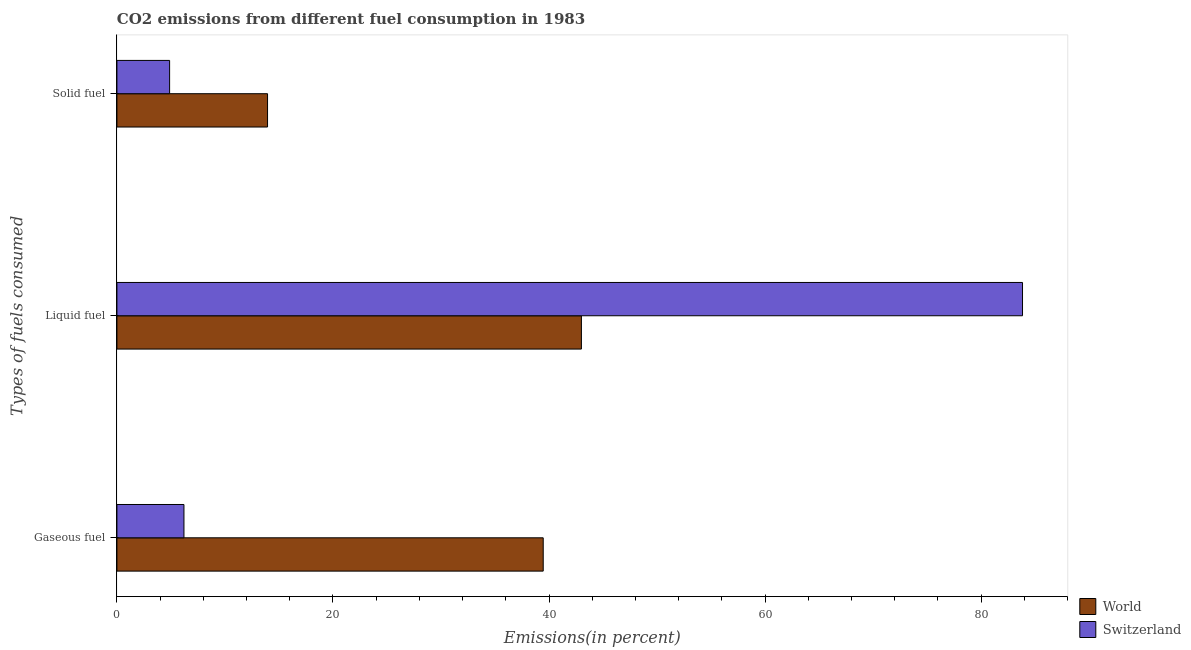Are the number of bars per tick equal to the number of legend labels?
Keep it short and to the point. Yes. How many bars are there on the 3rd tick from the top?
Your answer should be compact. 2. How many bars are there on the 2nd tick from the bottom?
Give a very brief answer. 2. What is the label of the 2nd group of bars from the top?
Give a very brief answer. Liquid fuel. What is the percentage of solid fuel emission in Switzerland?
Give a very brief answer. 4.88. Across all countries, what is the maximum percentage of gaseous fuel emission?
Give a very brief answer. 39.46. Across all countries, what is the minimum percentage of gaseous fuel emission?
Provide a short and direct response. 6.2. In which country was the percentage of solid fuel emission minimum?
Ensure brevity in your answer.  Switzerland. What is the total percentage of liquid fuel emission in the graph?
Provide a short and direct response. 126.83. What is the difference between the percentage of gaseous fuel emission in World and that in Switzerland?
Ensure brevity in your answer.  33.26. What is the difference between the percentage of liquid fuel emission in Switzerland and the percentage of gaseous fuel emission in World?
Give a very brief answer. 44.37. What is the average percentage of liquid fuel emission per country?
Your answer should be compact. 63.41. What is the difference between the percentage of liquid fuel emission and percentage of solid fuel emission in Switzerland?
Offer a terse response. 78.95. In how many countries, is the percentage of solid fuel emission greater than 60 %?
Keep it short and to the point. 0. What is the ratio of the percentage of solid fuel emission in World to that in Switzerland?
Ensure brevity in your answer.  2.86. What is the difference between the highest and the second highest percentage of gaseous fuel emission?
Provide a short and direct response. 33.26. What is the difference between the highest and the lowest percentage of gaseous fuel emission?
Your answer should be compact. 33.26. What does the 1st bar from the top in Solid fuel represents?
Provide a succinct answer. Switzerland. What does the 2nd bar from the bottom in Solid fuel represents?
Your answer should be very brief. Switzerland. How many bars are there?
Ensure brevity in your answer.  6. Are the values on the major ticks of X-axis written in scientific E-notation?
Give a very brief answer. No. Does the graph contain grids?
Offer a terse response. No. How many legend labels are there?
Keep it short and to the point. 2. What is the title of the graph?
Give a very brief answer. CO2 emissions from different fuel consumption in 1983. What is the label or title of the X-axis?
Offer a very short reply. Emissions(in percent). What is the label or title of the Y-axis?
Offer a terse response. Types of fuels consumed. What is the Emissions(in percent) of World in Gaseous fuel?
Offer a terse response. 39.46. What is the Emissions(in percent) of Switzerland in Gaseous fuel?
Keep it short and to the point. 6.2. What is the Emissions(in percent) in World in Liquid fuel?
Keep it short and to the point. 43. What is the Emissions(in percent) in Switzerland in Liquid fuel?
Make the answer very short. 83.83. What is the Emissions(in percent) in World in Solid fuel?
Make the answer very short. 13.94. What is the Emissions(in percent) in Switzerland in Solid fuel?
Give a very brief answer. 4.88. Across all Types of fuels consumed, what is the maximum Emissions(in percent) in World?
Give a very brief answer. 43. Across all Types of fuels consumed, what is the maximum Emissions(in percent) of Switzerland?
Your response must be concise. 83.83. Across all Types of fuels consumed, what is the minimum Emissions(in percent) in World?
Give a very brief answer. 13.94. Across all Types of fuels consumed, what is the minimum Emissions(in percent) of Switzerland?
Your response must be concise. 4.88. What is the total Emissions(in percent) in World in the graph?
Your response must be concise. 96.4. What is the total Emissions(in percent) in Switzerland in the graph?
Your response must be concise. 94.91. What is the difference between the Emissions(in percent) of World in Gaseous fuel and that in Liquid fuel?
Provide a short and direct response. -3.54. What is the difference between the Emissions(in percent) in Switzerland in Gaseous fuel and that in Liquid fuel?
Make the answer very short. -77.62. What is the difference between the Emissions(in percent) of World in Gaseous fuel and that in Solid fuel?
Offer a terse response. 25.52. What is the difference between the Emissions(in percent) in Switzerland in Gaseous fuel and that in Solid fuel?
Make the answer very short. 1.33. What is the difference between the Emissions(in percent) in World in Liquid fuel and that in Solid fuel?
Provide a succinct answer. 29.05. What is the difference between the Emissions(in percent) of Switzerland in Liquid fuel and that in Solid fuel?
Make the answer very short. 78.95. What is the difference between the Emissions(in percent) in World in Gaseous fuel and the Emissions(in percent) in Switzerland in Liquid fuel?
Keep it short and to the point. -44.37. What is the difference between the Emissions(in percent) in World in Gaseous fuel and the Emissions(in percent) in Switzerland in Solid fuel?
Offer a very short reply. 34.58. What is the difference between the Emissions(in percent) of World in Liquid fuel and the Emissions(in percent) of Switzerland in Solid fuel?
Make the answer very short. 38.12. What is the average Emissions(in percent) of World per Types of fuels consumed?
Offer a terse response. 32.13. What is the average Emissions(in percent) of Switzerland per Types of fuels consumed?
Make the answer very short. 31.64. What is the difference between the Emissions(in percent) in World and Emissions(in percent) in Switzerland in Gaseous fuel?
Your response must be concise. 33.26. What is the difference between the Emissions(in percent) in World and Emissions(in percent) in Switzerland in Liquid fuel?
Provide a short and direct response. -40.83. What is the difference between the Emissions(in percent) of World and Emissions(in percent) of Switzerland in Solid fuel?
Make the answer very short. 9.07. What is the ratio of the Emissions(in percent) in World in Gaseous fuel to that in Liquid fuel?
Ensure brevity in your answer.  0.92. What is the ratio of the Emissions(in percent) of Switzerland in Gaseous fuel to that in Liquid fuel?
Give a very brief answer. 0.07. What is the ratio of the Emissions(in percent) of World in Gaseous fuel to that in Solid fuel?
Your answer should be compact. 2.83. What is the ratio of the Emissions(in percent) in Switzerland in Gaseous fuel to that in Solid fuel?
Your answer should be very brief. 1.27. What is the ratio of the Emissions(in percent) of World in Liquid fuel to that in Solid fuel?
Make the answer very short. 3.08. What is the ratio of the Emissions(in percent) in Switzerland in Liquid fuel to that in Solid fuel?
Offer a terse response. 17.19. What is the difference between the highest and the second highest Emissions(in percent) of World?
Keep it short and to the point. 3.54. What is the difference between the highest and the second highest Emissions(in percent) of Switzerland?
Make the answer very short. 77.62. What is the difference between the highest and the lowest Emissions(in percent) in World?
Give a very brief answer. 29.05. What is the difference between the highest and the lowest Emissions(in percent) of Switzerland?
Offer a very short reply. 78.95. 